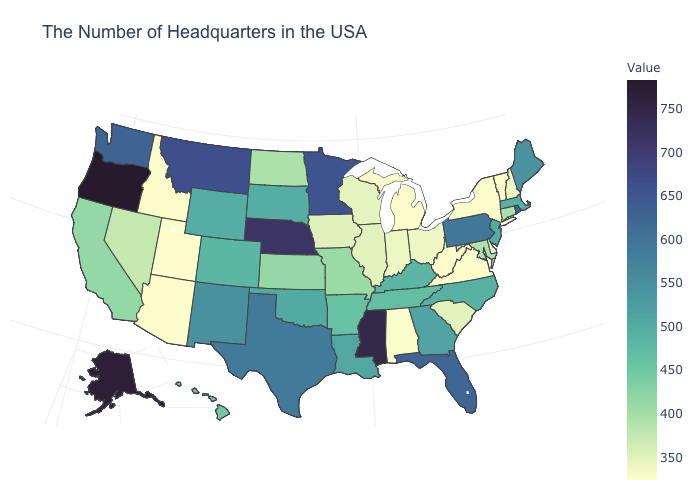Does Oregon have the highest value in the USA?
Give a very brief answer. Yes. Is the legend a continuous bar?
Concise answer only. Yes. Does Wyoming have a higher value than Texas?
Be succinct. No. Does Texas have the highest value in the South?
Be succinct. No. Which states have the highest value in the USA?
Give a very brief answer. Oregon. Among the states that border South Dakota , which have the highest value?
Short answer required. Nebraska. Does Mississippi have the highest value in the South?
Keep it brief. Yes. 